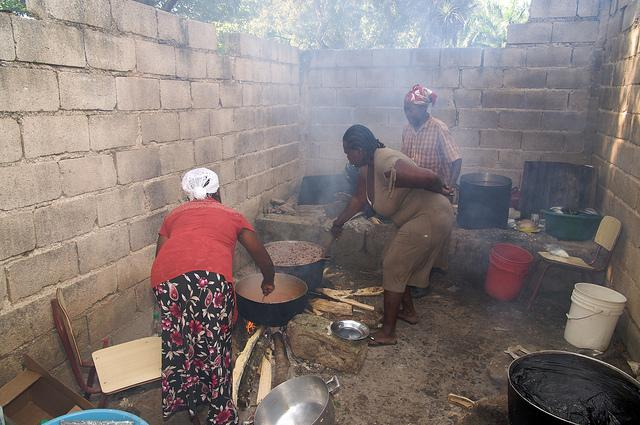What are the women doing over the large containers on the ground?

Choices:
A) washing
B) cleaning
C) lighting fire
D) cooking cooking 